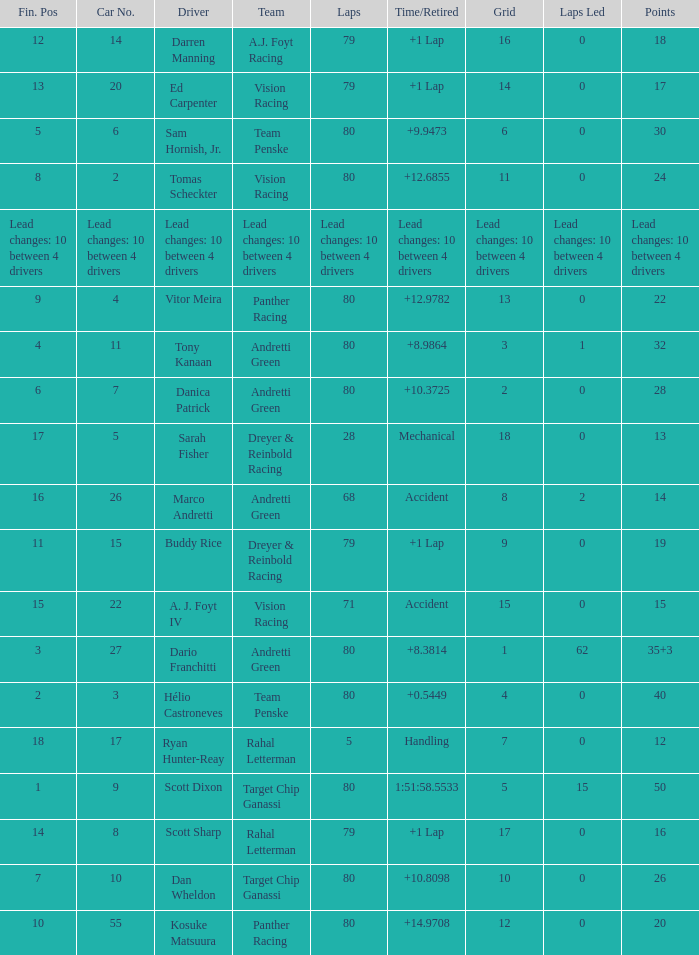Can you tell me the points tally for driver kosuke matsuura? 20.0. 